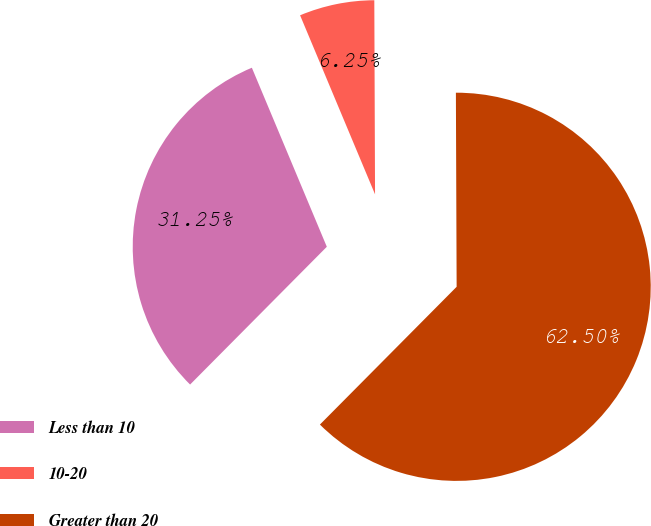Convert chart. <chart><loc_0><loc_0><loc_500><loc_500><pie_chart><fcel>Less than 10<fcel>10-20<fcel>Greater than 20<nl><fcel>31.25%<fcel>6.25%<fcel>62.5%<nl></chart> 